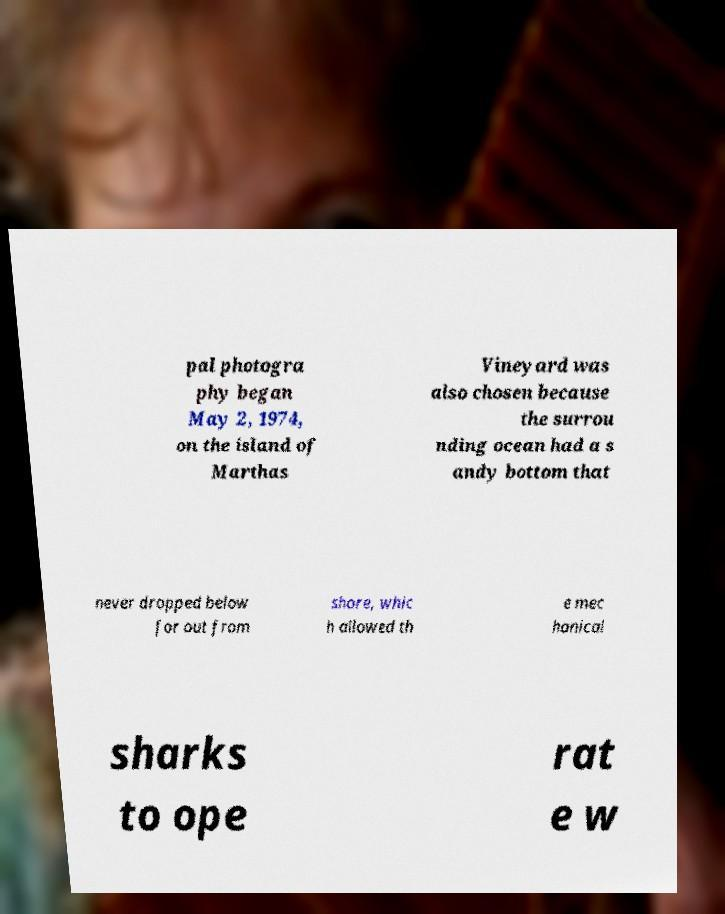For documentation purposes, I need the text within this image transcribed. Could you provide that? pal photogra phy began May 2, 1974, on the island of Marthas Vineyard was also chosen because the surrou nding ocean had a s andy bottom that never dropped below for out from shore, whic h allowed th e mec hanical sharks to ope rat e w 